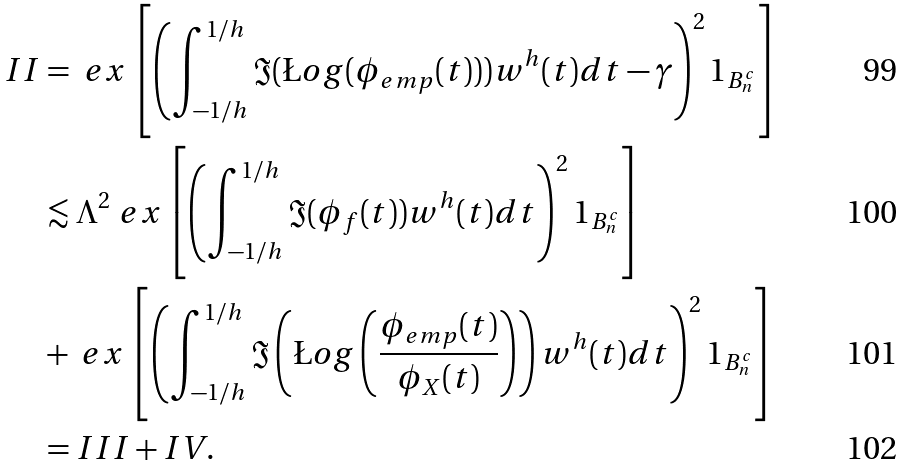<formula> <loc_0><loc_0><loc_500><loc_500>I I & = \ e x \left [ \left ( \int _ { - 1 / h } ^ { 1 / h } \Im ( \L o g ( \phi _ { e m p } ( t ) ) ) w ^ { h } ( t ) d t - \gamma \right ) ^ { 2 } 1 _ { B _ { n } ^ { c } } \right ] \\ & \lesssim \Lambda ^ { 2 } \ e x \left [ \left ( \int _ { - 1 / h } ^ { 1 / h } \Im ( \phi _ { f } ( t ) ) w ^ { h } ( t ) d t \right ) ^ { 2 } 1 _ { B _ { n } ^ { c } } \right ] \\ & + \ e x \left [ \left ( \int _ { - 1 / h } ^ { 1 / h } \Im \left ( \L o g \left ( \frac { \phi _ { e m p } ( t ) } { \phi _ { X } ( t ) } \right ) \right ) w ^ { h } ( t ) d t \right ) ^ { 2 } 1 _ { B _ { n } ^ { c } } \right ] \\ & = I I I + I V .</formula> 